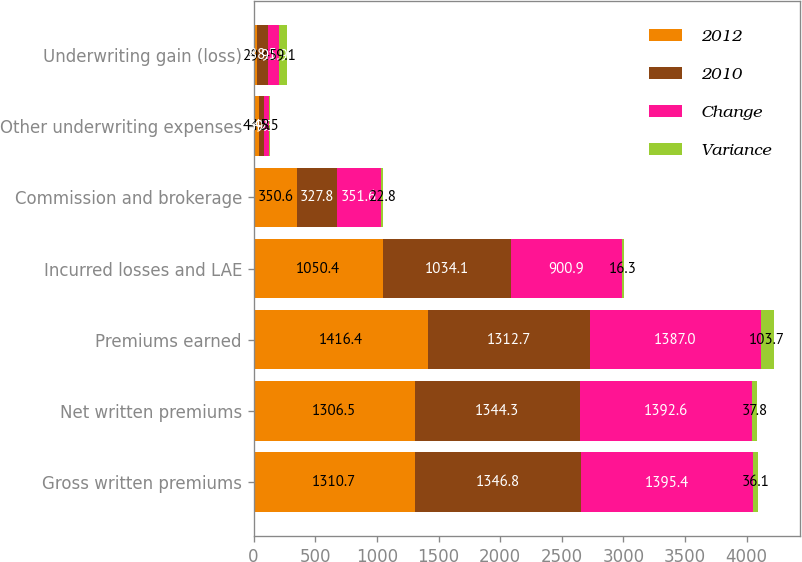Convert chart. <chart><loc_0><loc_0><loc_500><loc_500><stacked_bar_chart><ecel><fcel>Gross written premiums<fcel>Net written premiums<fcel>Premiums earned<fcel>Incurred losses and LAE<fcel>Commission and brokerage<fcel>Other underwriting expenses<fcel>Underwriting gain (loss)<nl><fcel>2012<fcel>1310.7<fcel>1306.5<fcel>1416.4<fcel>1050.4<fcel>350.6<fcel>44.8<fcel>29.4<nl><fcel>2010<fcel>1346.8<fcel>1344.3<fcel>1312.7<fcel>1034.1<fcel>327.8<fcel>39.3<fcel>88.5<nl><fcel>Change<fcel>1395.4<fcel>1392.6<fcel>1387<fcel>900.9<fcel>351.6<fcel>42.5<fcel>91.9<nl><fcel>Variance<fcel>36.1<fcel>37.8<fcel>103.7<fcel>16.3<fcel>22.8<fcel>5.5<fcel>59.1<nl></chart> 